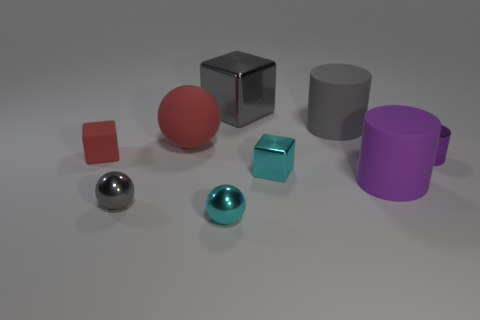Which objects appear to have a metallic finish? The objects with a metallic finish are the silver sphere, which has a chrome-like appearance, and the small copper-colored cube, giving them a reflective quality that stands out from the matte finishes of the other objects. 